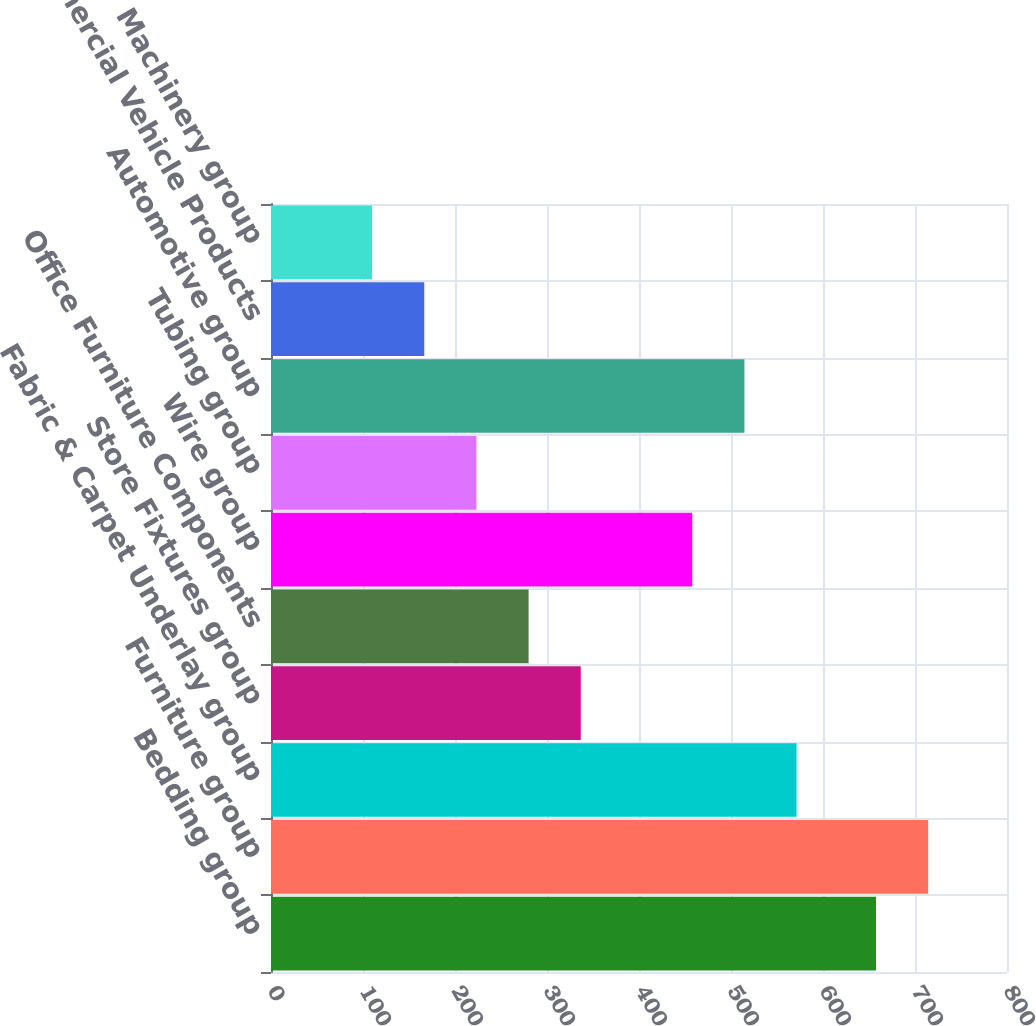<chart> <loc_0><loc_0><loc_500><loc_500><bar_chart><fcel>Bedding group<fcel>Furniture group<fcel>Fabric & Carpet Underlay group<fcel>Store Fixtures group<fcel>Office Furniture Components<fcel>Wire group<fcel>Tubing group<fcel>Automotive group<fcel>Commercial Vehicle Products<fcel>Machinery group<nl><fcel>657.6<fcel>714.3<fcel>571.3<fcel>336.7<fcel>280<fcel>457.9<fcel>223.3<fcel>514.6<fcel>166.6<fcel>109.9<nl></chart> 